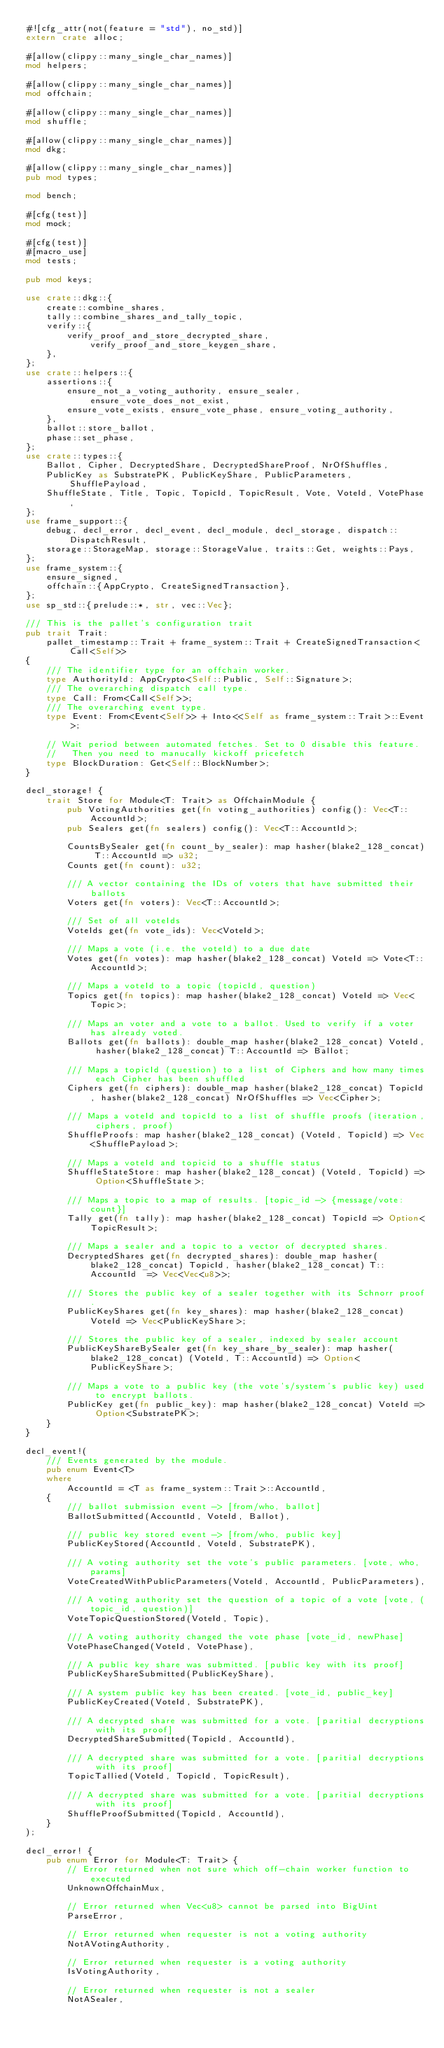<code> <loc_0><loc_0><loc_500><loc_500><_Rust_>#![cfg_attr(not(feature = "std"), no_std)]
extern crate alloc;

#[allow(clippy::many_single_char_names)]
mod helpers;

#[allow(clippy::many_single_char_names)]
mod offchain;

#[allow(clippy::many_single_char_names)]
mod shuffle;

#[allow(clippy::many_single_char_names)]
mod dkg;

#[allow(clippy::many_single_char_names)]
pub mod types;

mod bench;

#[cfg(test)]
mod mock;

#[cfg(test)]
#[macro_use]
mod tests;

pub mod keys;

use crate::dkg::{
    create::combine_shares,
    tally::combine_shares_and_tally_topic,
    verify::{
        verify_proof_and_store_decrypted_share, verify_proof_and_store_keygen_share,
    },
};
use crate::helpers::{
    assertions::{
        ensure_not_a_voting_authority, ensure_sealer, ensure_vote_does_not_exist,
        ensure_vote_exists, ensure_vote_phase, ensure_voting_authority,
    },
    ballot::store_ballot,
    phase::set_phase,
};
use crate::types::{
    Ballot, Cipher, DecryptedShare, DecryptedShareProof, NrOfShuffles,
    PublicKey as SubstratePK, PublicKeyShare, PublicParameters, ShufflePayload,
    ShuffleState, Title, Topic, TopicId, TopicResult, Vote, VoteId, VotePhase,
};
use frame_support::{
    debug, decl_error, decl_event, decl_module, decl_storage, dispatch::DispatchResult,
    storage::StorageMap, storage::StorageValue, traits::Get, weights::Pays,
};
use frame_system::{
    ensure_signed,
    offchain::{AppCrypto, CreateSignedTransaction},
};
use sp_std::{prelude::*, str, vec::Vec};

/// This is the pallet's configuration trait
pub trait Trait:
    pallet_timestamp::Trait + frame_system::Trait + CreateSignedTransaction<Call<Self>>
{
    /// The identifier type for an offchain worker.
    type AuthorityId: AppCrypto<Self::Public, Self::Signature>;
    /// The overarching dispatch call type.
    type Call: From<Call<Self>>;
    /// The overarching event type.
    type Event: From<Event<Self>> + Into<<Self as frame_system::Trait>::Event>;

    // Wait period between automated fetches. Set to 0 disable this feature.
    //   Then you need to manucally kickoff pricefetch
    type BlockDuration: Get<Self::BlockNumber>;
}

decl_storage! {
    trait Store for Module<T: Trait> as OffchainModule {
        pub VotingAuthorities get(fn voting_authorities) config(): Vec<T::AccountId>;
        pub Sealers get(fn sealers) config(): Vec<T::AccountId>;

        CountsBySealer get(fn count_by_sealer): map hasher(blake2_128_concat) T::AccountId => u32;
        Counts get(fn count): u32;

        /// A vector containing the IDs of voters that have submitted their ballots
        Voters get(fn voters): Vec<T::AccountId>;

        /// Set of all voteIds
        VoteIds get(fn vote_ids): Vec<VoteId>;

        /// Maps a vote (i.e. the voteId) to a due date
        Votes get(fn votes): map hasher(blake2_128_concat) VoteId => Vote<T::AccountId>;

        /// Maps a voteId to a topic (topicId, question)
        Topics get(fn topics): map hasher(blake2_128_concat) VoteId => Vec<Topic>;

        /// Maps an voter and a vote to a ballot. Used to verify if a voter has already voted.
        Ballots get(fn ballots): double_map hasher(blake2_128_concat) VoteId, hasher(blake2_128_concat) T::AccountId => Ballot;

        /// Maps a topicId (question) to a list of Ciphers and how many times each Cipher has been shuffled
        Ciphers get(fn ciphers): double_map hasher(blake2_128_concat) TopicId, hasher(blake2_128_concat) NrOfShuffles => Vec<Cipher>;

        /// Maps a voteId and topicId to a list of shuffle proofs (iteration, ciphers, proof)
        ShuffleProofs: map hasher(blake2_128_concat) (VoteId, TopicId) => Vec<ShufflePayload>;

        /// Maps a voteId and topicid to a shuffle status
        ShuffleStateStore: map hasher(blake2_128_concat) (VoteId, TopicId) => Option<ShuffleState>;

        /// Maps a topic to a map of results. [topic_id -> {message/vote: count}]
        Tally get(fn tally): map hasher(blake2_128_concat) TopicId => Option<TopicResult>;

        /// Maps a sealer and a topic to a vector of decrypted shares.
        DecryptedShares get(fn decrypted_shares): double_map hasher(blake2_128_concat) TopicId, hasher(blake2_128_concat) T::AccountId  => Vec<Vec<u8>>;

        /// Stores the public key of a sealer together with its Schnorr proof.
        PublicKeyShares get(fn key_shares): map hasher(blake2_128_concat) VoteId => Vec<PublicKeyShare>;

        /// Stores the public key of a sealer, indexed by sealer account
        PublicKeyShareBySealer get(fn key_share_by_sealer): map hasher(blake2_128_concat) (VoteId, T::AccountId) => Option<PublicKeyShare>;

        /// Maps a vote to a public key (the vote's/system's public key) used to encrypt ballots.
        PublicKey get(fn public_key): map hasher(blake2_128_concat) VoteId => Option<SubstratePK>;
    }
}

decl_event!(
    /// Events generated by the module.
    pub enum Event<T>
    where
        AccountId = <T as frame_system::Trait>::AccountId,
    {
        /// ballot submission event -> [from/who, ballot]
        BallotSubmitted(AccountId, VoteId, Ballot),

        /// public key stored event -> [from/who, public key]
        PublicKeyStored(AccountId, VoteId, SubstratePK),

        /// A voting authority set the vote's public parameters. [vote, who, params]
        VoteCreatedWithPublicParameters(VoteId, AccountId, PublicParameters),

        /// A voting authority set the question of a topic of a vote [vote, (topic_id, question)]
        VoteTopicQuestionStored(VoteId, Topic),

        /// A voting authority changed the vote phase [vote_id, newPhase]
        VotePhaseChanged(VoteId, VotePhase),

        /// A public key share was submitted. [public key with its proof]
        PublicKeyShareSubmitted(PublicKeyShare),

        /// A system public key has been created. [vote_id, public_key]
        PublicKeyCreated(VoteId, SubstratePK),

        /// A decrypted share was submitted for a vote. [paritial decryptions with its proof]
        DecryptedShareSubmitted(TopicId, AccountId),

        /// A decrypted share was submitted for a vote. [paritial decryptions with its proof]
        TopicTallied(VoteId, TopicId, TopicResult),

        /// A decrypted share was submitted for a vote. [paritial decryptions with its proof]
        ShuffleProofSubmitted(TopicId, AccountId),
    }
);

decl_error! {
    pub enum Error for Module<T: Trait> {
        // Error returned when not sure which off-chain worker function to executed
        UnknownOffchainMux,

        // Error returned when Vec<u8> cannot be parsed into BigUint
        ParseError,

        // Error returned when requester is not a voting authority
        NotAVotingAuthority,

        // Error returned when requester is a voting authority
        IsVotingAuthority,

        // Error returned when requester is not a sealer
        NotASealer,
</code> 